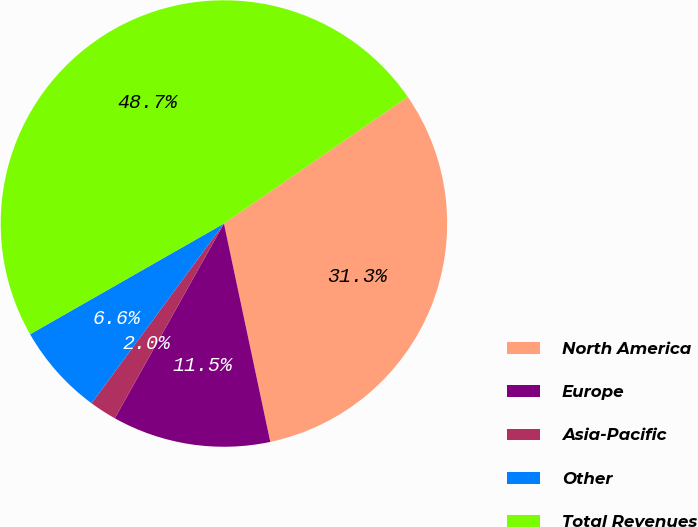Convert chart. <chart><loc_0><loc_0><loc_500><loc_500><pie_chart><fcel>North America<fcel>Europe<fcel>Asia-Pacific<fcel>Other<fcel>Total Revenues<nl><fcel>31.27%<fcel>11.46%<fcel>1.97%<fcel>6.64%<fcel>48.66%<nl></chart> 